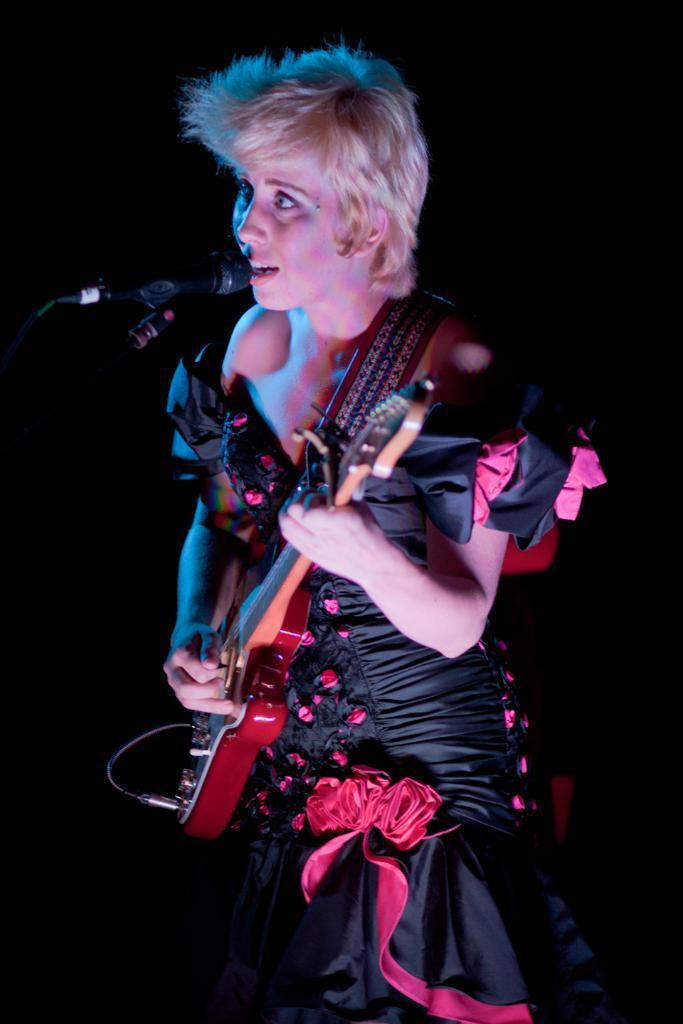Who is the main subject in the image? There is a woman in the image. What is the woman doing in the image? The woman is standing in front of a mic and holding a guitar. What is the woman wearing in the image? The woman is wearing a black and pink dress. How would you describe the background of the image? The background of the image is dark. What type of disease is the woman suffering from in the image? There is no indication in the image that the woman is suffering from any disease. Can you tell me how many vans are parked behind the woman in the image? There are no vans present in the image. 